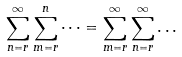<formula> <loc_0><loc_0><loc_500><loc_500>\sum _ { n = r } ^ { \infty } \sum _ { m = r } ^ { n } \dots = \sum _ { m = r } ^ { \infty } \sum _ { n = r } ^ { \infty } \dots</formula> 